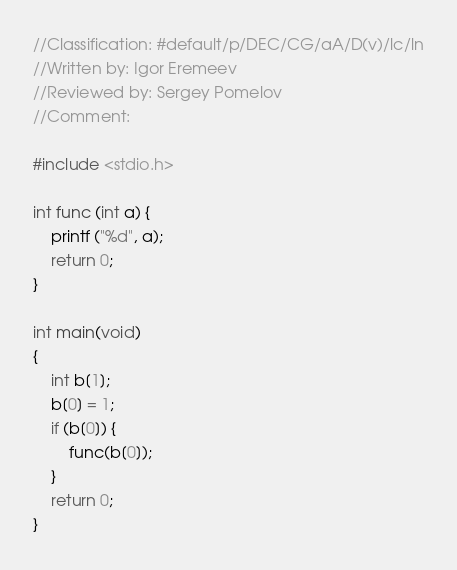Convert code to text. <code><loc_0><loc_0><loc_500><loc_500><_C_>//Classification: #default/p/DEC/CG/aA/D(v)/lc/ln
//Written by: Igor Eremeev
//Reviewed by: Sergey Pomelov
//Comment:

#include <stdio.h>

int func (int a) {
	printf ("%d", a);
	return 0;
}

int main(void)
{
	int b[1];
	b[0] = 1;
	if (b[0]) {
		func(b[0]);
	}
	return 0;
}
</code> 